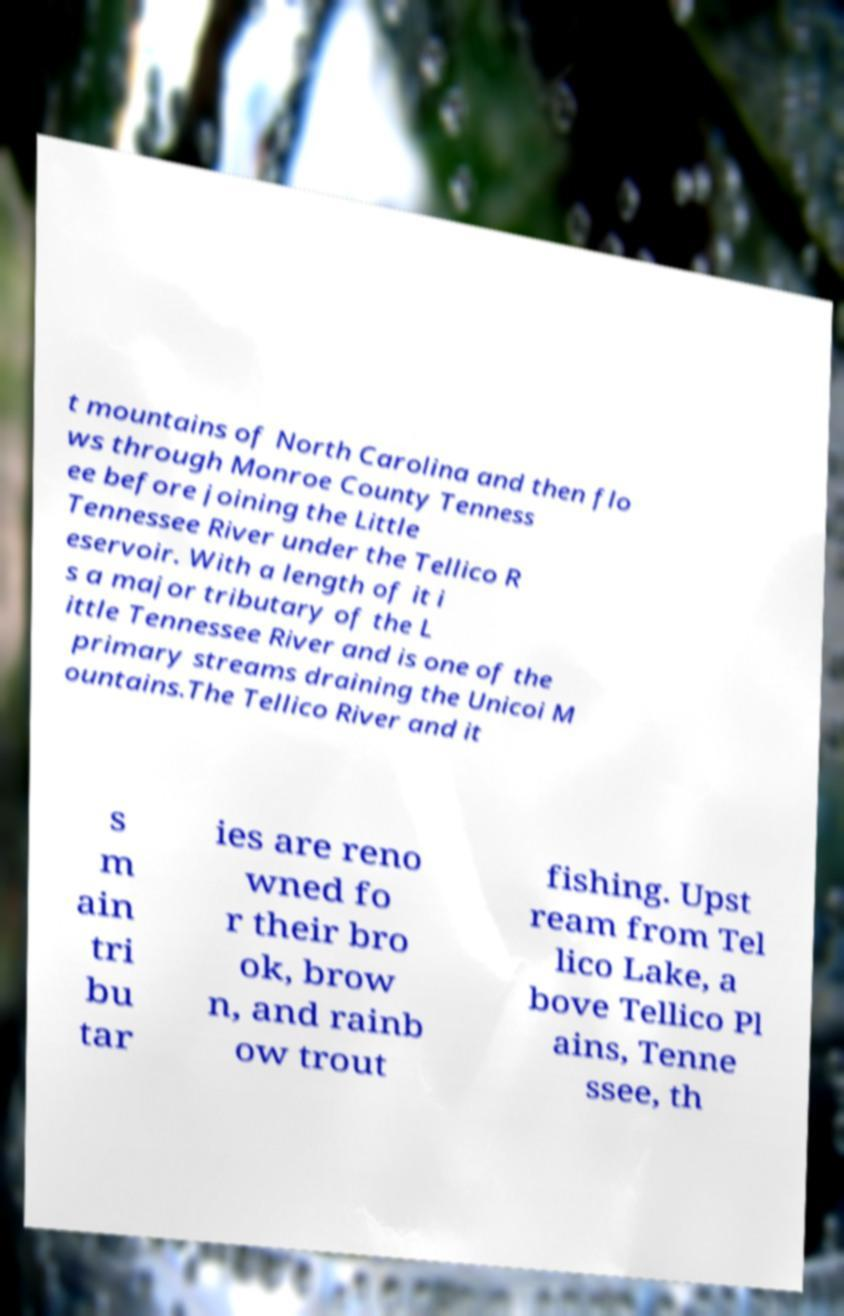What messages or text are displayed in this image? I need them in a readable, typed format. t mountains of North Carolina and then flo ws through Monroe County Tenness ee before joining the Little Tennessee River under the Tellico R eservoir. With a length of it i s a major tributary of the L ittle Tennessee River and is one of the primary streams draining the Unicoi M ountains.The Tellico River and it s m ain tri bu tar ies are reno wned fo r their bro ok, brow n, and rainb ow trout fishing. Upst ream from Tel lico Lake, a bove Tellico Pl ains, Tenne ssee, th 